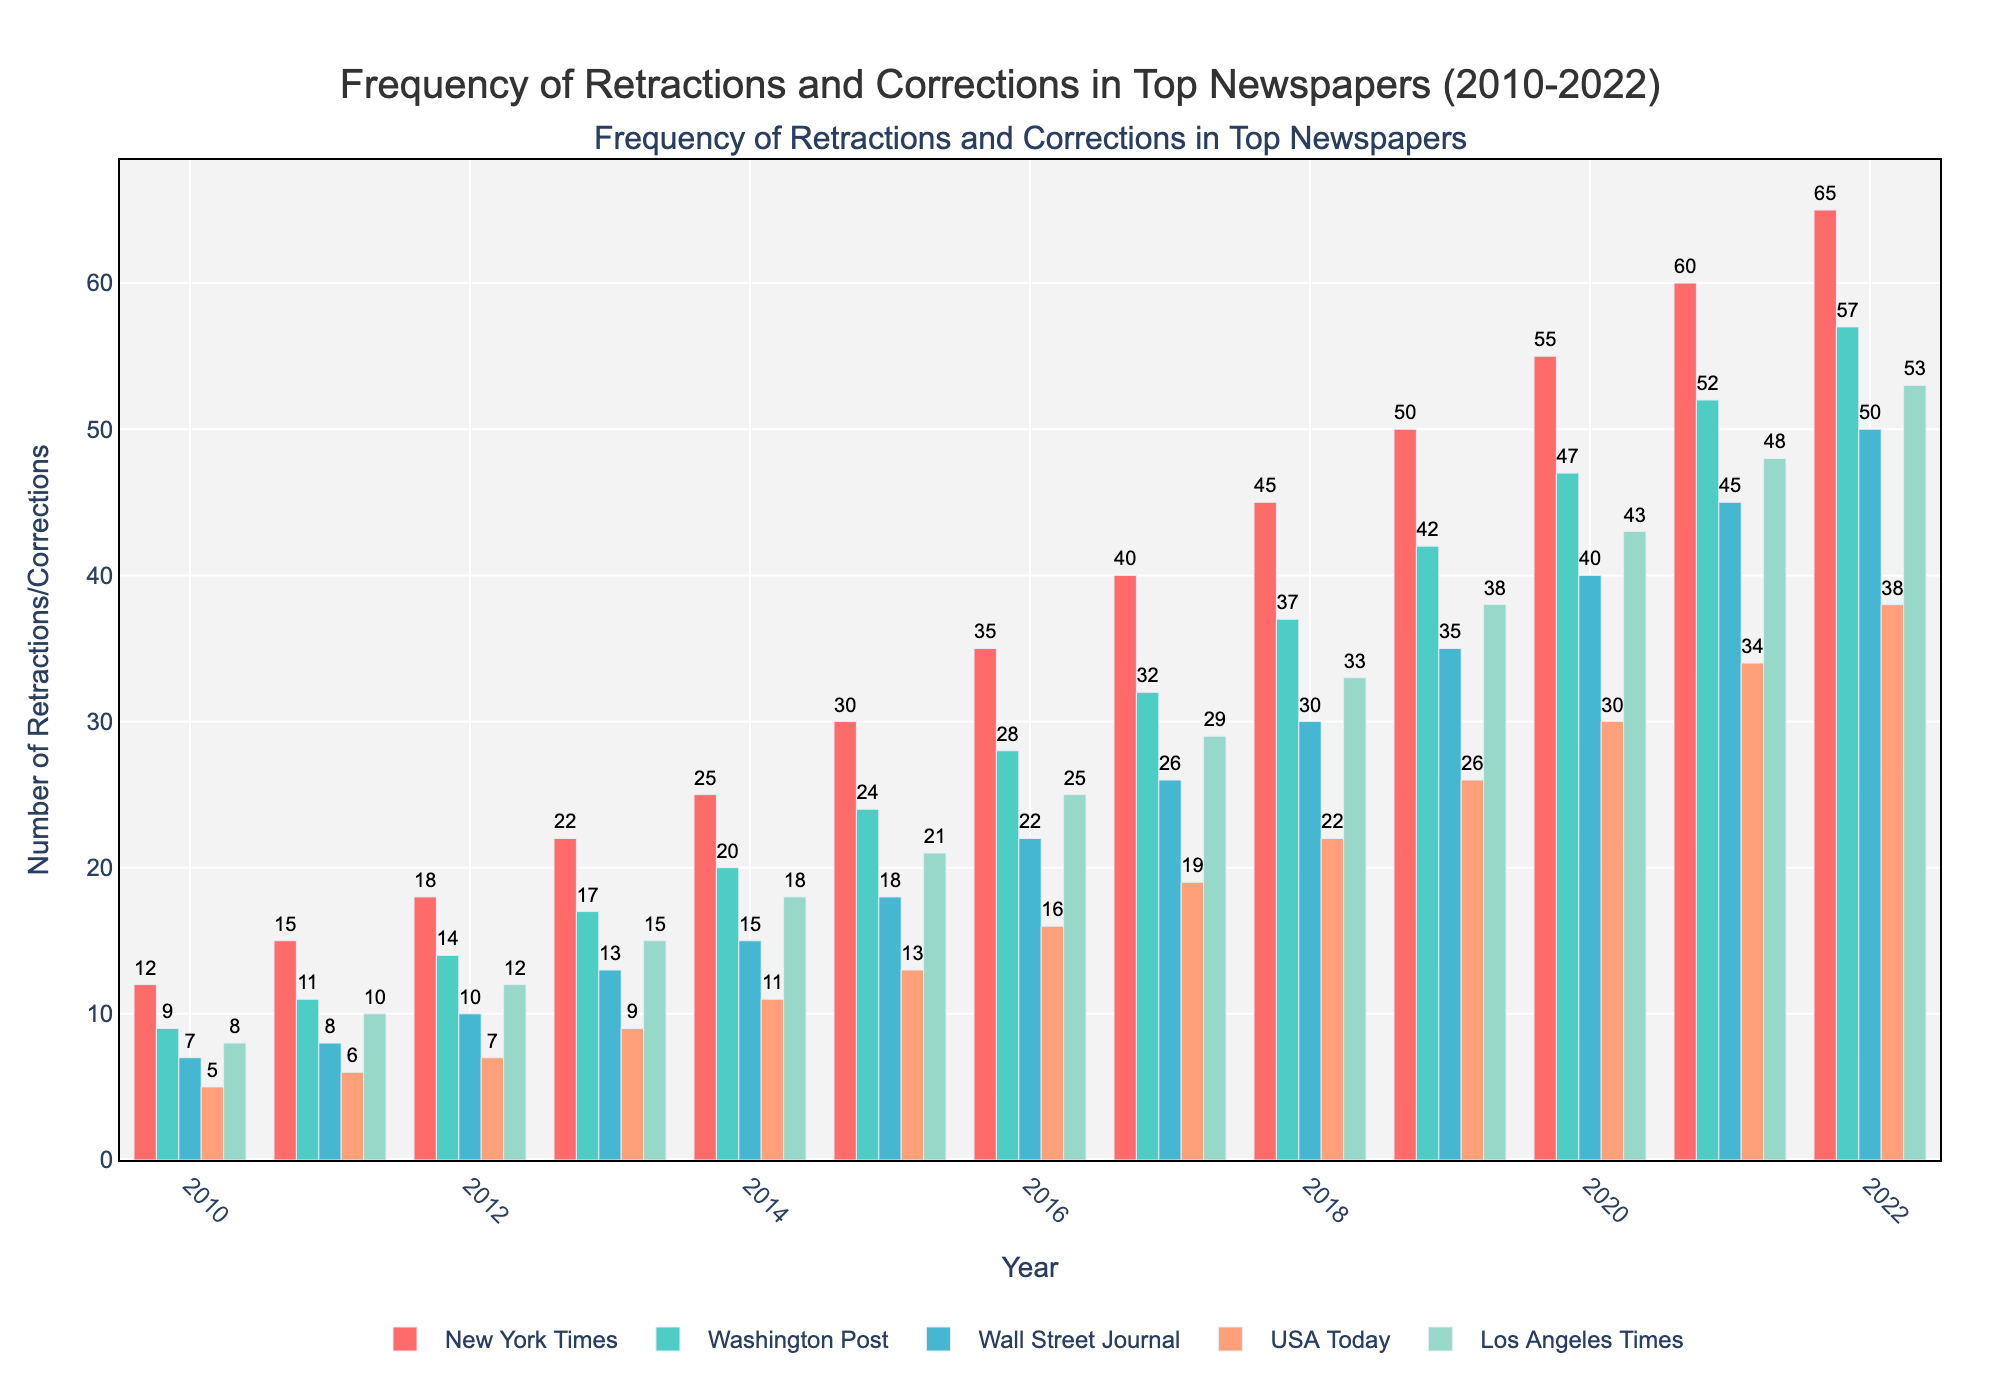What is the total number of retractions and corrections for the New York Times from 2010 to 2022? Sum up the number of retractions and corrections for each year for the New York Times: 12 + 15 + 18 + 22 + 25 + 30 + 35 + 40 + 45 + 50 + 55 + 60 + 65 = 462
Answer: 462 Which newspaper had the highest number of retractions and corrections in 2020? Visually inspect the height of the bars for 2020 and identify the tallest one. The New York Times had the tallest bar in 2020 with 55 retractions/corrections.
Answer: New York Times Compare the number of retractions and corrections for the Washington Post and the Wall Street Journal in 2015. Which was greater and by how much? In 2015, the Washington Post had 24 retractions/corrections and the Wall Street Journal had 18. The difference is 24 - 18 = 6.
Answer: Washington Post by 6 What is the color of the bar representing the frequency of retractions and corrections for USA Today? Visually identify the color of the bars for USA Today, which is a shade of orange.
Answer: Orange Calculate the average number of retractions and corrections for the Los Angeles Times over the period 2010-2022. The numbers for each year are: 8, 10, 12, 15, 18, 21, 25, 29, 33, 38, 43, 48, 53. Sum them up: 355. There are 13 years, so the average is 355 / 13 = ~27.31
Answer: ~27.31 Which year(s) saw a simultaneous increase in the number of retractions and corrections for all newspapers compared to the previous year? Identify the years where each newspaper's bar is higher than the previous year’s bar. This occurs every year from 2010 to 2022.
Answer: 2011-2022 By how much did the frequency of retractions and corrections for USA Today increase from 2011 to 2016? In 2011, USA Today had 6 retractions/corrections, and in 2016 it had 16. The increase is 16 - 6 = 10.
Answer: 10 What trend can be observed in the frequency of retractions and corrections for the New York Times over the years from 2010 to 2022? The height of the bars representing the New York Times consistently increases from 2010 to 2022, indicating a steady upward trend.
Answer: Upward trend Compare the frequency of retractions and corrections for the Wall Street Journal and Los Angeles Times in 2012. Which had fewer, and by how much? In 2012, the Wall Street Journal had 10 retractions/corrections, and the Los Angeles Times had 12. The difference is 12 - 10 = 2.
Answer: Wall Street Journal by 2 